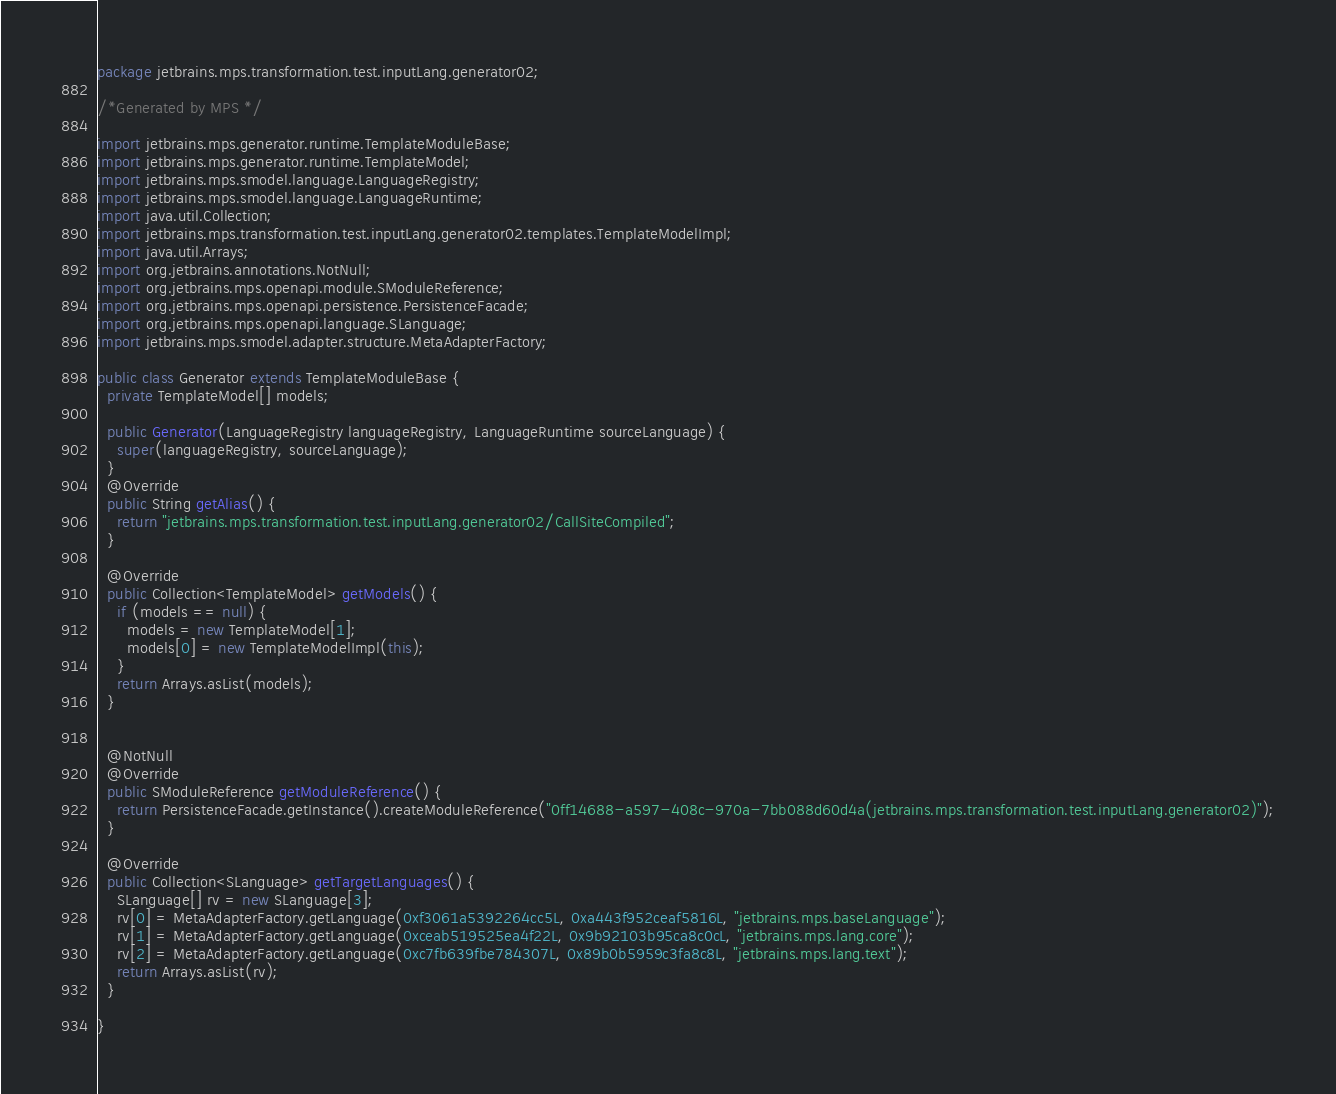<code> <loc_0><loc_0><loc_500><loc_500><_Java_>package jetbrains.mps.transformation.test.inputLang.generator02;

/*Generated by MPS */

import jetbrains.mps.generator.runtime.TemplateModuleBase;
import jetbrains.mps.generator.runtime.TemplateModel;
import jetbrains.mps.smodel.language.LanguageRegistry;
import jetbrains.mps.smodel.language.LanguageRuntime;
import java.util.Collection;
import jetbrains.mps.transformation.test.inputLang.generator02.templates.TemplateModelImpl;
import java.util.Arrays;
import org.jetbrains.annotations.NotNull;
import org.jetbrains.mps.openapi.module.SModuleReference;
import org.jetbrains.mps.openapi.persistence.PersistenceFacade;
import org.jetbrains.mps.openapi.language.SLanguage;
import jetbrains.mps.smodel.adapter.structure.MetaAdapterFactory;

public class Generator extends TemplateModuleBase {
  private TemplateModel[] models;

  public Generator(LanguageRegistry languageRegistry, LanguageRuntime sourceLanguage) {
    super(languageRegistry, sourceLanguage);
  }
  @Override
  public String getAlias() {
    return "jetbrains.mps.transformation.test.inputLang.generator02/CallSiteCompiled";
  }

  @Override
  public Collection<TemplateModel> getModels() {
    if (models == null) {
      models = new TemplateModel[1];
      models[0] = new TemplateModelImpl(this);
    }
    return Arrays.asList(models);
  }


  @NotNull
  @Override
  public SModuleReference getModuleReference() {
    return PersistenceFacade.getInstance().createModuleReference("0ff14688-a597-408c-970a-7bb088d60d4a(jetbrains.mps.transformation.test.inputLang.generator02)");
  }

  @Override
  public Collection<SLanguage> getTargetLanguages() {
    SLanguage[] rv = new SLanguage[3];
    rv[0] = MetaAdapterFactory.getLanguage(0xf3061a5392264cc5L, 0xa443f952ceaf5816L, "jetbrains.mps.baseLanguage");
    rv[1] = MetaAdapterFactory.getLanguage(0xceab519525ea4f22L, 0x9b92103b95ca8c0cL, "jetbrains.mps.lang.core");
    rv[2] = MetaAdapterFactory.getLanguage(0xc7fb639fbe784307L, 0x89b0b5959c3fa8c8L, "jetbrains.mps.lang.text");
    return Arrays.asList(rv);
  }

}
</code> 